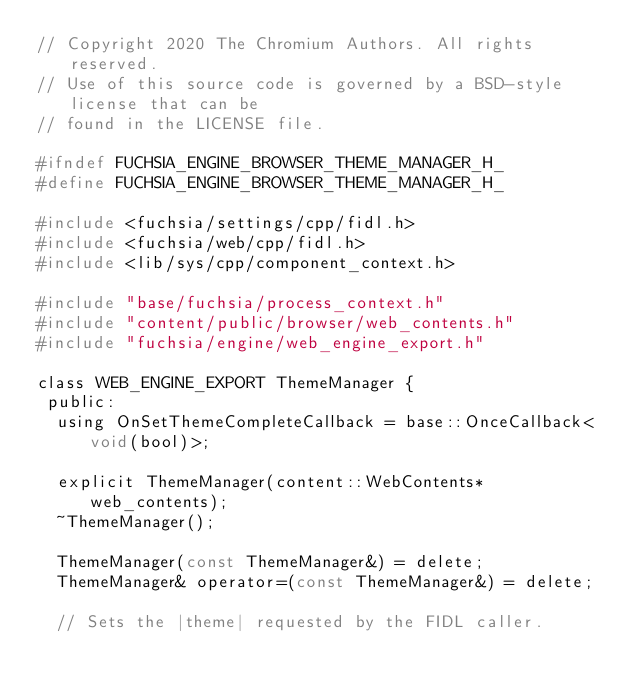Convert code to text. <code><loc_0><loc_0><loc_500><loc_500><_C_>// Copyright 2020 The Chromium Authors. All rights reserved.
// Use of this source code is governed by a BSD-style license that can be
// found in the LICENSE file.

#ifndef FUCHSIA_ENGINE_BROWSER_THEME_MANAGER_H_
#define FUCHSIA_ENGINE_BROWSER_THEME_MANAGER_H_

#include <fuchsia/settings/cpp/fidl.h>
#include <fuchsia/web/cpp/fidl.h>
#include <lib/sys/cpp/component_context.h>

#include "base/fuchsia/process_context.h"
#include "content/public/browser/web_contents.h"
#include "fuchsia/engine/web_engine_export.h"

class WEB_ENGINE_EXPORT ThemeManager {
 public:
  using OnSetThemeCompleteCallback = base::OnceCallback<void(bool)>;

  explicit ThemeManager(content::WebContents* web_contents);
  ~ThemeManager();

  ThemeManager(const ThemeManager&) = delete;
  ThemeManager& operator=(const ThemeManager&) = delete;

  // Sets the |theme| requested by the FIDL caller.</code> 